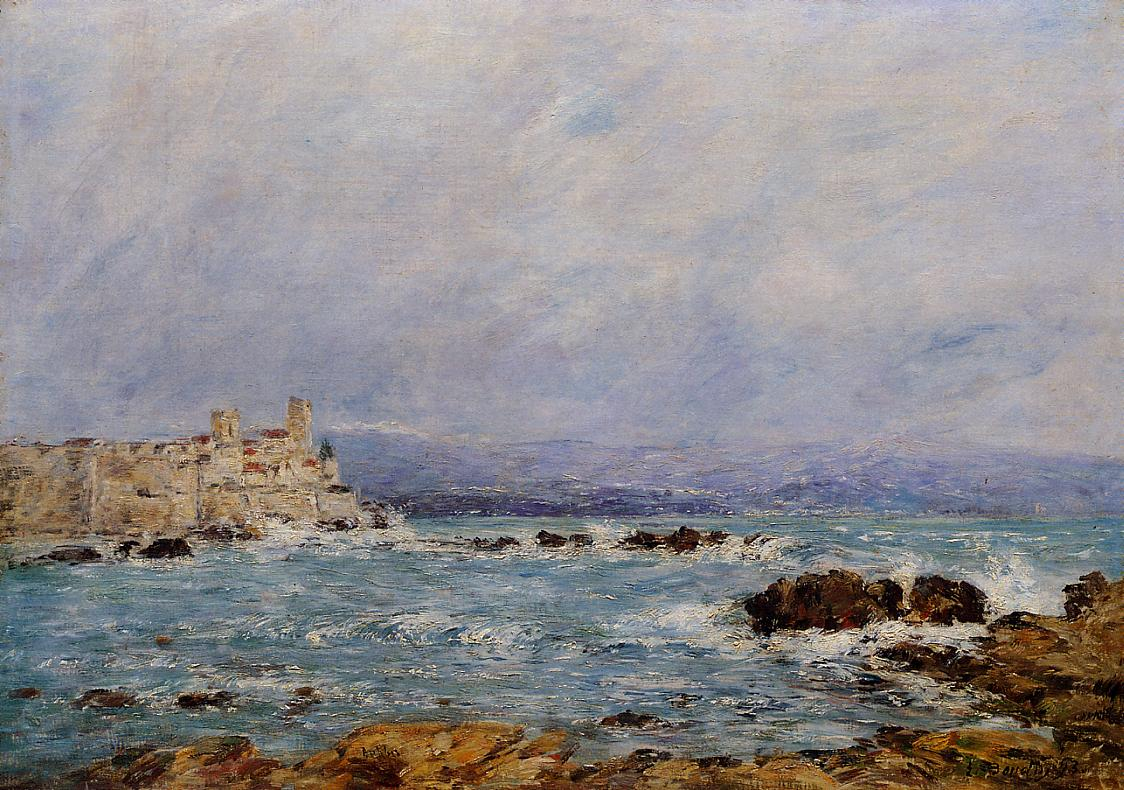Describe a realistic scenario where someone might experience this view in real life? In real life, someone might experience this view while standing atop a windswept cliff along a rugged coastline. As they look out at the vast expanse of the sea, they would feel the breeze rustle through their hair and the salty spray of the ocean on their face. They might turn to see an old castle in the distance, perched on the edge of the cliff, a sentinel watching over the crashing waves below. The sky, with its soft blues and gentle clouds, would add to the serene atmosphere, creating a moment of introspection and connection to nature. Could you write a short poem inspired by this image? By the shore where waves do crest,
A castle stands, old and blessed.
With mossy rocks and sea so blue,
Whispers of the past break through.
Sky of light with clouds so fair,
Time stands still in salty air. 